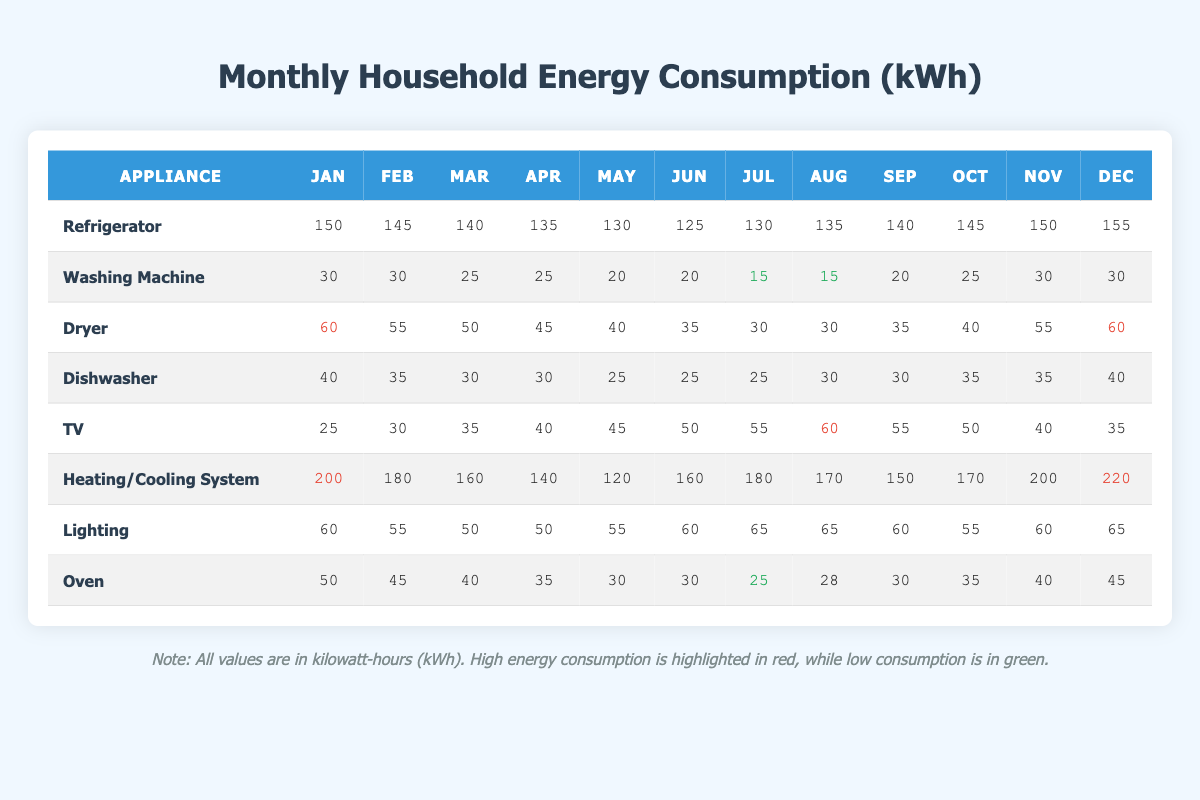What is the energy consumption of the TV in August? The table indicates that for the TV in August, the energy consumption is 60 kWh. This can be found directly under the August column for the TV row.
Answer: 60 kWh During which month did the Dishwasher consume the least amount of energy? By scanning the Dishwasher row, it shows that the least energy consumption was in May with a value of 25 kWh, which is the lowest among all the monthly readings for that appliance.
Answer: May What is the total energy consumption of the Refrigerator from January to June? To find this, sum the monthly values in the Refrigerator row for the first six months: 150 + 145 + 140 + 135 + 130 + 125 = 925. Thus, the total energy consumption for that period is 925 kWh.
Answer: 925 kWh Did the energy consumption of the Heating System decrease from January to April? Looking at the Heating System row, the values are 200 (January), 180 (February), 160 (March), and 140 (April). Each month shows a decrease from the previous month, confirming the trend of decreased energy consumption.
Answer: Yes What is the average energy consumption of the Washing Machine for the entire year? First, we find the sum of the energy consumption for the Washing Machine across all months: 30 + 30 + 25 + 25 + 20 + 20 + 15 + 15 + 20 + 25 + 30 + 30 =  305. There are 12 months, so the average is 305/12 = approximately 25.42.
Answer: 25.42 kWh In which month did the Cooling System use the highest energy? The Cooling System appears with values for June (160), July (180), August (170), September (150), and does not appear in the other months. July had the highest value at 180 kWh, which is greater than the other months listed.
Answer: July What was the total energy consumption for the Dishwasher from March to December? For this, we add the values from March to December: 30 (Mar) + 30 (Apr) + 25 (May) + 25 (Jun) + 25 (Jul) + 30 (Aug) + 30 (Sep) + 35 (Oct) + 35 (Nov) + 40 (Dec) =  25 + 30 + 30 + 25 + 30 + 30 + 35 + 35 + 40 =  300 kWh.
Answer: 300 kWh Is the energy consumed by the Oven higher in January or October? In January, the Oven consumed 50 kWh, while in October it consumed 35 kWh. Comparing both values shows that January had higher consumption than October.
Answer: January What is the difference in energy consumption of the Dryer between November and December? The Dryer consumed 55 kWh in November and 60 kWh in December. Calculating the difference: 60 - 55 = 5 kWh shows that December's consumption is 5 kWh higher than November's.
Answer: 5 kWh 